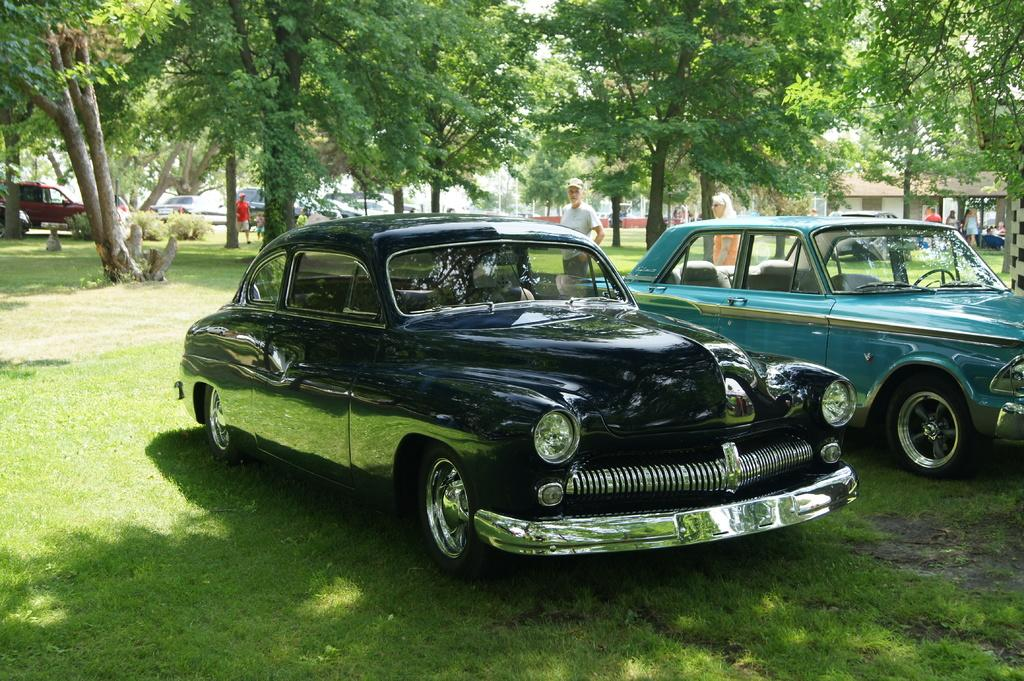How many cars can be seen in the image? There are two cars in the image. What is the person in the image doing? The person is standing in the middle of the image. Can you describe the person's attire? The person is wearing clothes. What can be seen in the background of the image? There are trees in the background of the image. What type of force is being applied to the person in the image? There is no indication of any force being applied to the person in the image; they are simply standing. 